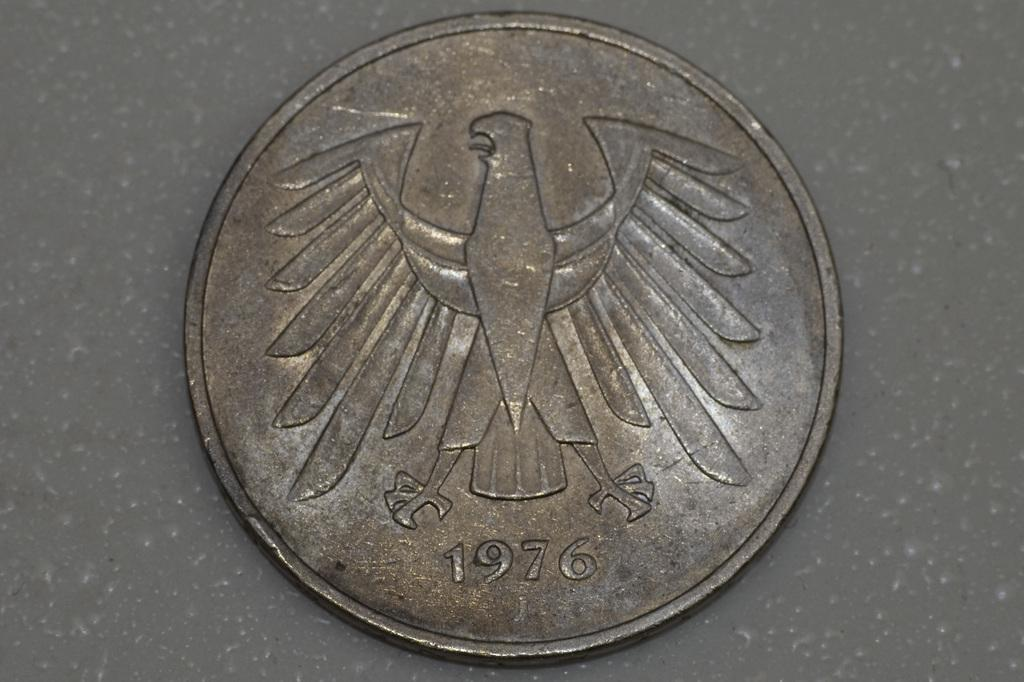<image>
Render a clear and concise summary of the photo. An old coin from 1976 that has an eagle emblem on it. 